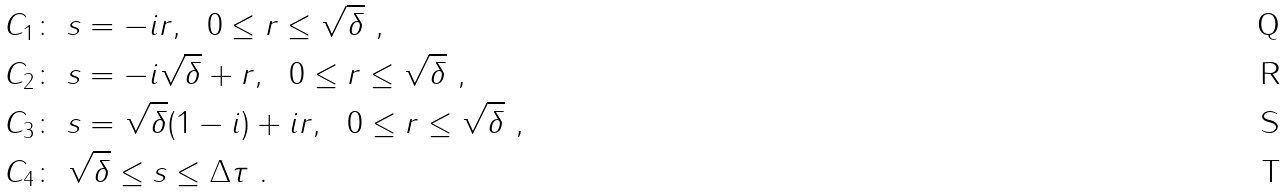Convert formula to latex. <formula><loc_0><loc_0><loc_500><loc_500>& C _ { 1 } \colon \ s = - i r , \ \ 0 \leq r \leq \sqrt { \delta } \ , \\ & C _ { 2 } \colon \ s = - i \sqrt { \delta } + r , \ \ 0 \leq r \leq \sqrt { \delta } \ , \\ & C _ { 3 } \colon \ s = \sqrt { \delta } ( 1 - i ) + i r , \ \ 0 \leq r \leq \sqrt { \delta } \ , \\ & C _ { 4 } \colon \ \sqrt { \delta } \leq s \leq \Delta \tau \ .</formula> 